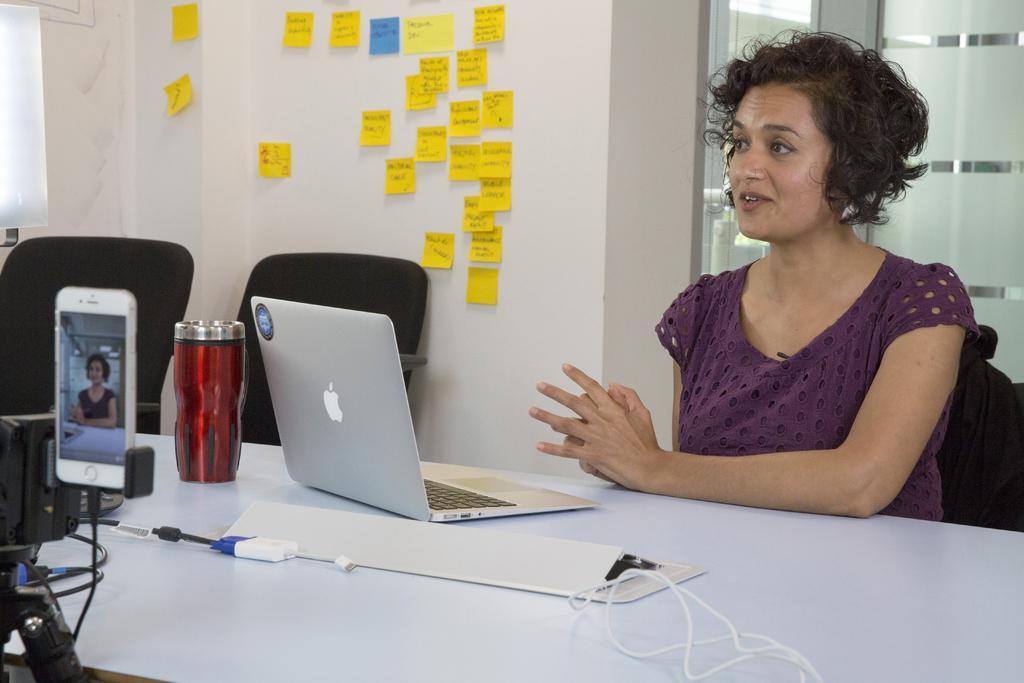Could you give a brief overview of what you see in this image? In the image in the right a lady wearing a purple t-shirt is sitting , she is talking something as her mouth is open. In front of her on a table there is laptop,bottle. In the left a camera panned on her. In the background there are chairs, sticky notes on the wall and a glass window. 